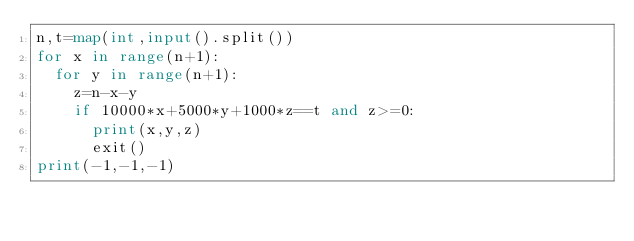<code> <loc_0><loc_0><loc_500><loc_500><_Python_>n,t=map(int,input().split())
for x in range(n+1):
  for y in range(n+1):
    z=n-x-y
    if 10000*x+5000*y+1000*z==t and z>=0:
      print(x,y,z)
      exit()
print(-1,-1,-1)</code> 